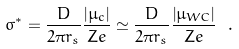Convert formula to latex. <formula><loc_0><loc_0><loc_500><loc_500>\sigma ^ { * } = \frac { D } { 2 \pi r _ { s } } \frac { \left | \mu _ { c } \right | } { Z e } \simeq \frac { D } { 2 \pi r _ { s } } \frac { \left | \mu _ { W C } \right | } { Z e } \ .</formula> 